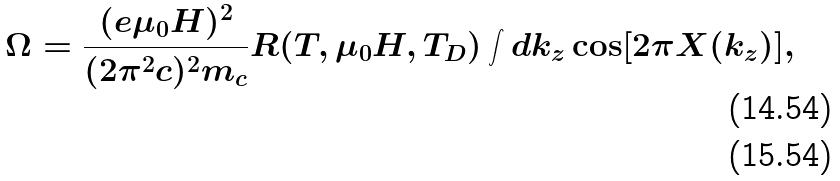Convert formula to latex. <formula><loc_0><loc_0><loc_500><loc_500>\Omega = \frac { ( e \mu _ { 0 } H ) ^ { 2 } } { ( 2 \pi ^ { 2 } c ) ^ { 2 } m _ { c } } R ( T , \mu _ { 0 } H , T _ { D } ) \int d k _ { z } \cos [ 2 \pi X ( k _ { z } ) ] , \\</formula> 